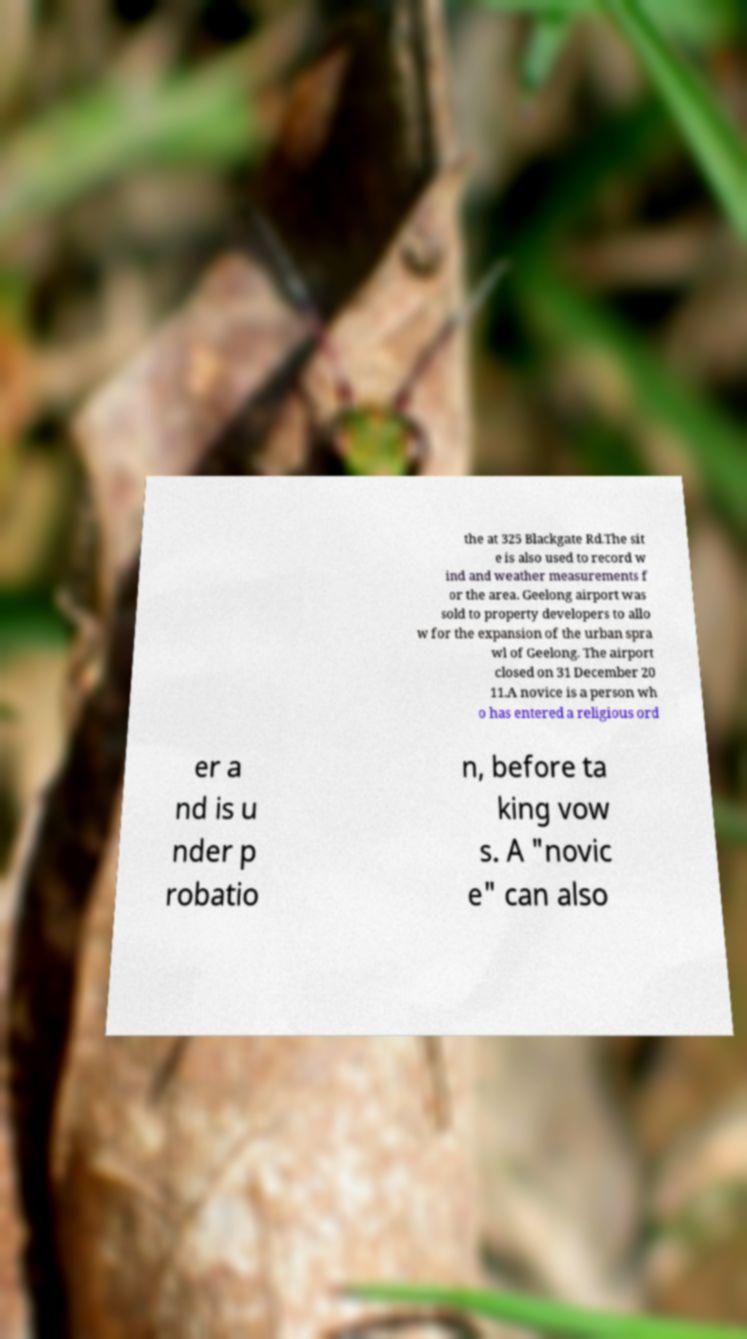Can you read and provide the text displayed in the image?This photo seems to have some interesting text. Can you extract and type it out for me? the at 325 Blackgate Rd.The sit e is also used to record w ind and weather measurements f or the area. Geelong airport was sold to property developers to allo w for the expansion of the urban spra wl of Geelong. The airport closed on 31 December 20 11.A novice is a person wh o has entered a religious ord er a nd is u nder p robatio n, before ta king vow s. A "novic e" can also 